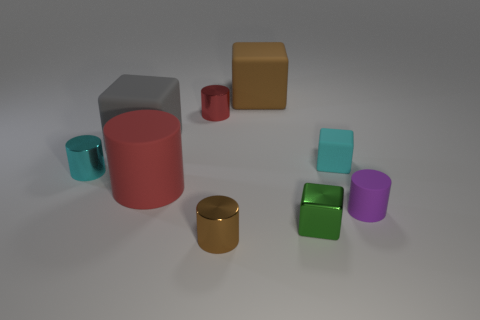Subtract all gray blocks. How many red cylinders are left? 2 Subtract 1 cylinders. How many cylinders are left? 4 Subtract all gray blocks. How many blocks are left? 3 Subtract all tiny shiny cylinders. How many cylinders are left? 2 Subtract all red cubes. Subtract all brown cylinders. How many cubes are left? 4 Subtract all blocks. How many objects are left? 5 Add 3 shiny cylinders. How many shiny cylinders exist? 6 Subtract 0 brown spheres. How many objects are left? 9 Subtract all tiny red cylinders. Subtract all large red rubber cylinders. How many objects are left? 7 Add 4 small cylinders. How many small cylinders are left? 8 